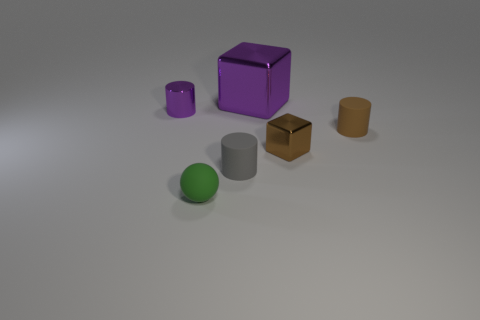What number of small objects are either purple spheres or brown cylinders?
Provide a short and direct response. 1. How big is the purple cylinder?
Offer a very short reply. Small. Is the number of balls right of the big thing greater than the number of big purple shiny things?
Ensure brevity in your answer.  No. Are there the same number of blocks that are right of the small brown matte thing and green rubber things that are to the left of the purple cylinder?
Offer a very short reply. Yes. The thing that is behind the small brown cube and right of the purple cube is what color?
Keep it short and to the point. Brown. Are there any other things that are the same size as the sphere?
Your answer should be very brief. Yes. Are there more small metal cubes in front of the gray thing than green balls that are in front of the big thing?
Make the answer very short. No. Is the size of the rubber thing in front of the gray thing the same as the big purple cube?
Your answer should be compact. No. What number of cylinders are on the left side of the metal cube in front of the cylinder left of the green rubber sphere?
Keep it short and to the point. 2. What is the size of the matte object that is both to the left of the purple cube and behind the tiny rubber ball?
Ensure brevity in your answer.  Small. 